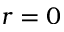Convert formula to latex. <formula><loc_0><loc_0><loc_500><loc_500>r = 0</formula> 